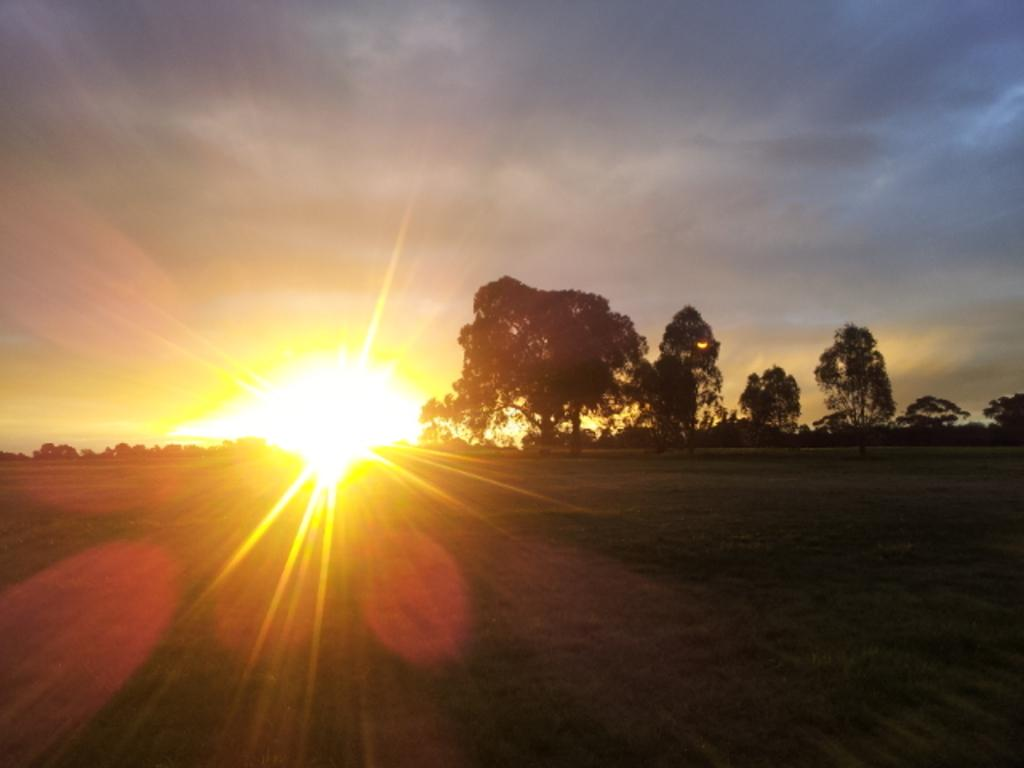What is happening to the sun in the image? The sun is rising in the sky in the image. What can be seen in the middle of the image? There are trees in the middle of the image. Where is the meeting of the fairies taking place in the image? There is no mention of fairies or a meeting in the image. 